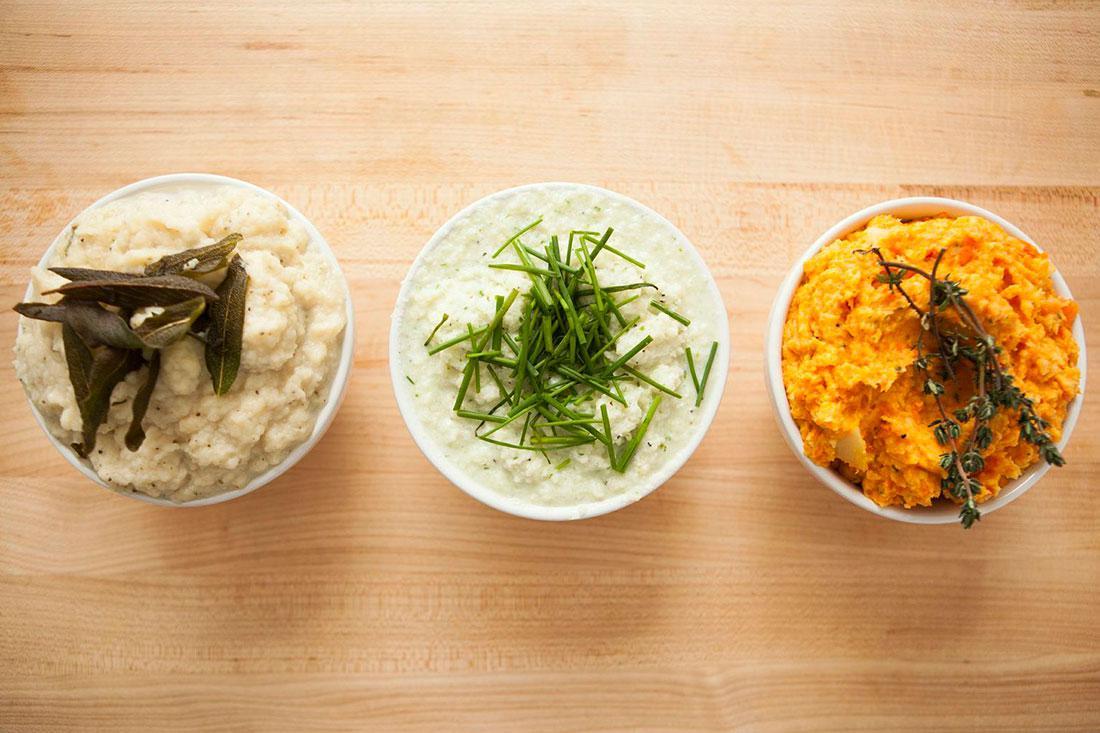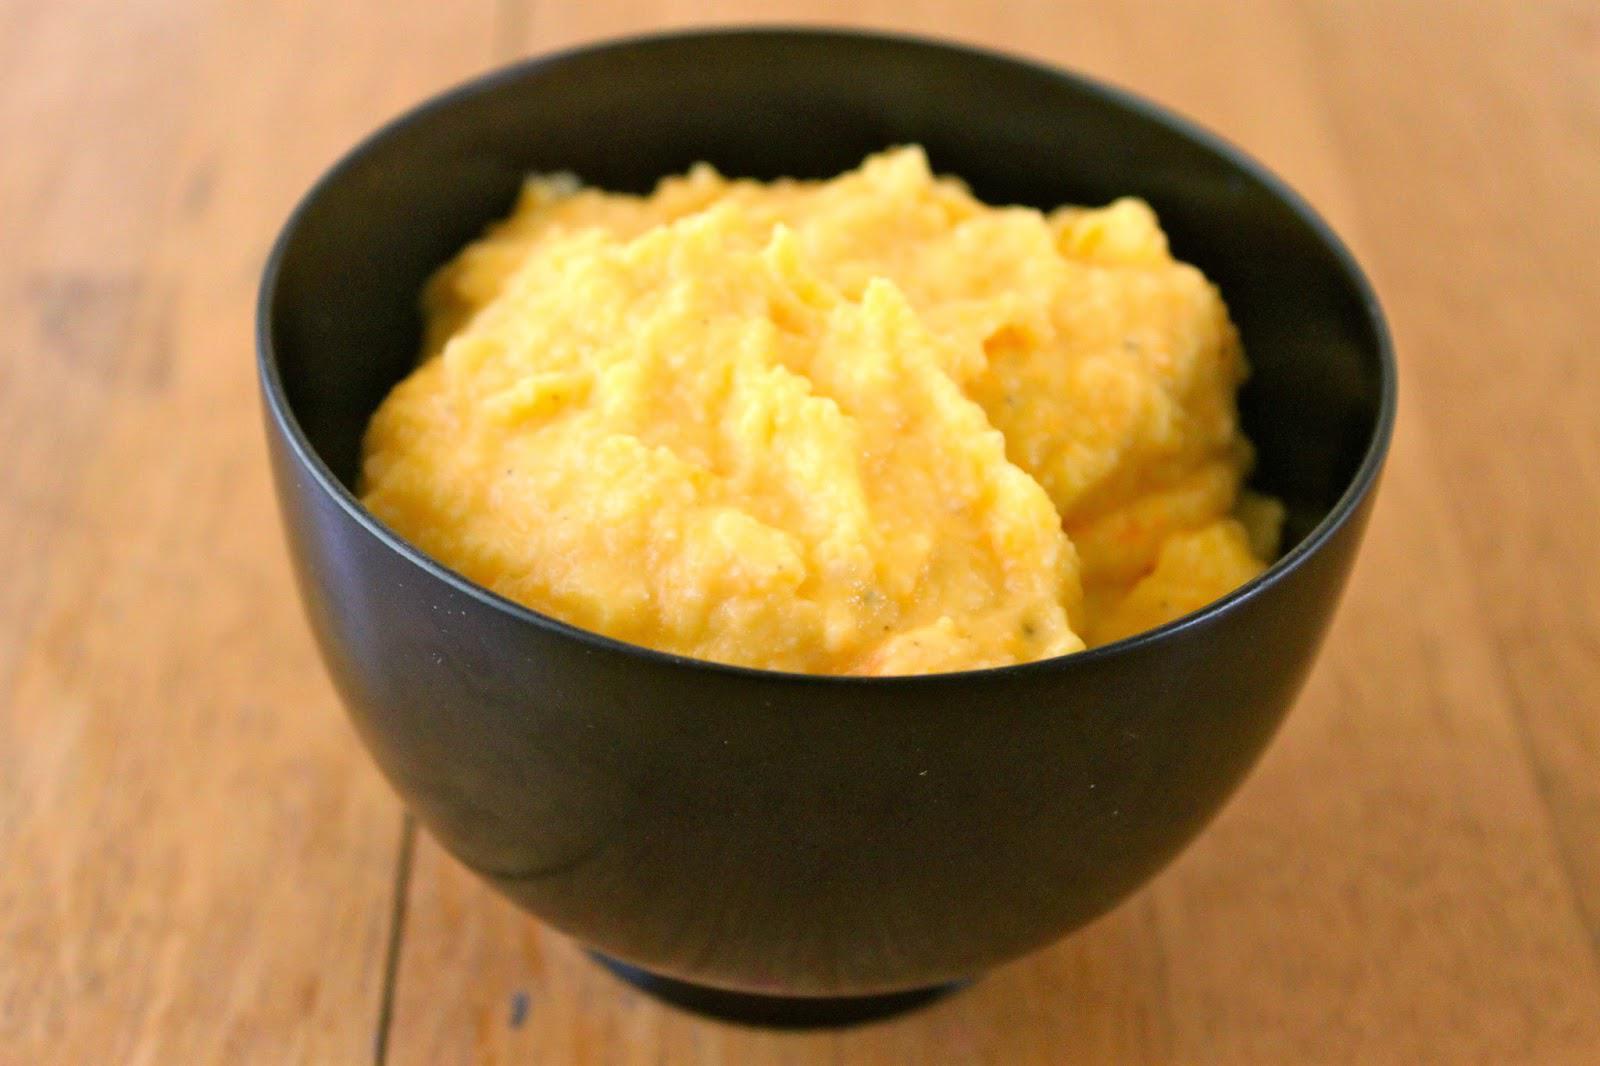The first image is the image on the left, the second image is the image on the right. Assess this claim about the two images: "All images include an item of silverware by a prepared potato dish.". Correct or not? Answer yes or no. No. The first image is the image on the left, the second image is the image on the right. Analyze the images presented: Is the assertion "There are three bowls in the left image." valid? Answer yes or no. Yes. 